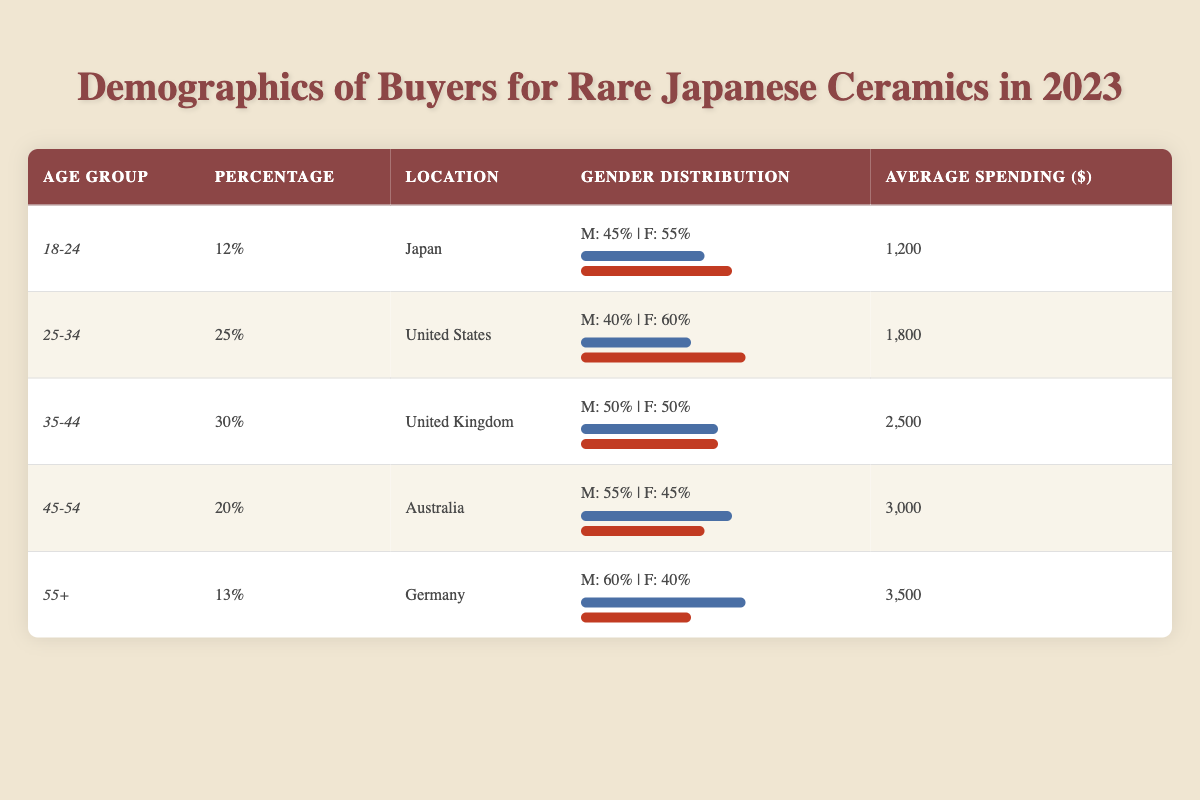What percentage of buyers are aged 25-34? The demographic segment for the age group 25-34 shows a percentage of 25% in the table.
Answer: 25% Which location has the highest average spending on rare Japanese ceramics? By comparing the average spending values, Germany has the highest average spending at $3,500.
Answer: Germany Is the gender distribution for the age group 45-54 evenly split? The gender distribution for the age group 45-54 shows males at 55% and females at 45%, which is not evenly split.
Answer: No What is the total percentage of buyers aged 18-24 and 25-34 combined? To find the total percentage for ages 18-24 and 25-34, we add their percentages: 12% + 25% = 37%.
Answer: 37% Which age group has the lowest average spending? Comparing the average spending across age groups, the 18-24 age group has the lowest average spending of $1,200.
Answer: 18-24 True or False: More females than males buy rare Japanese ceramics in the age group 55+. In the age group 55+, the gender distribution shows 60% male and 40% female, indicating that there are more males than females.
Answer: False What is the average spending for the age groups 35-44 and 45-54 combined? To get the average spending for these groups, add their spending: $2,500 + $3,000 = $5,500. Then, divide by 2 for the average: $5,500 / 2 = $2,750.
Answer: $2,750 Which location has more buyers, Japan or the United Kingdom? The percentage of buyers in Japan is 12%, while the United Kingdom has 30%. Thus, the United Kingdom has more buyers.
Answer: United Kingdom What is the gender ratio of male to female for the age group 25-34? For the age group 25-34, the gender distribution shows males at 40% and females at 60%. Therefore, the ratio is 40:60 or can be simplified to 2:3.
Answer: 2:3 Are there more buyers in the age group 45-54 or 55+? The percentages show that the age group 45-54 has 20% of buyers, while the 55+ age group has 13%. Therefore, there are more buyers in the 45-54 age group.
Answer: 45-54 